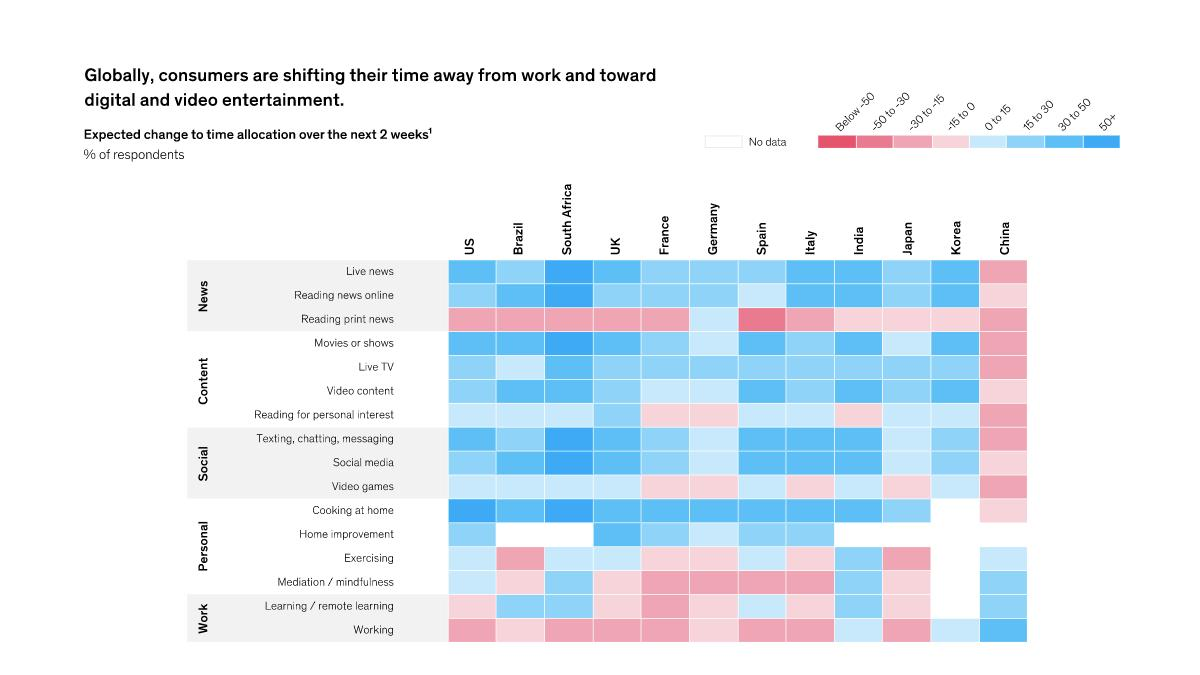Identify some key points in this picture. It is expected that people in China will decrease their time allocation for live TV in the future. The expected change in the time allocation by people in France for live news is either an increase or a decrease. The expected change in the time allocation of people in Brazil for exercising is either an increase or a decrease. There is a projected increase of more than 50% in the time allocation of people in South Africa for watching live news. The expected change in the time allocation of people in South Africa for cooking at home is expected to be around 50% or more. 